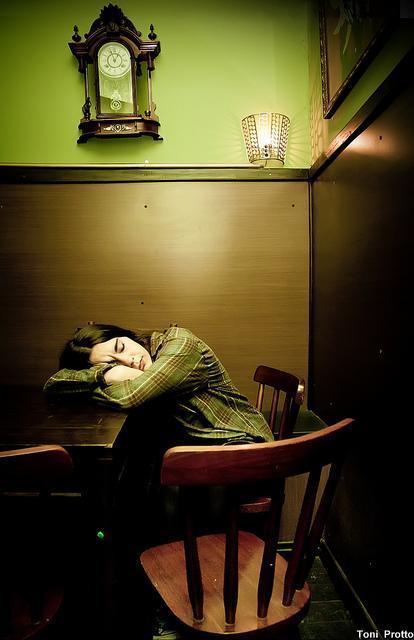How many chairs can be seen?
Give a very brief answer. 3. How many sheep are on the hillside?
Give a very brief answer. 0. 